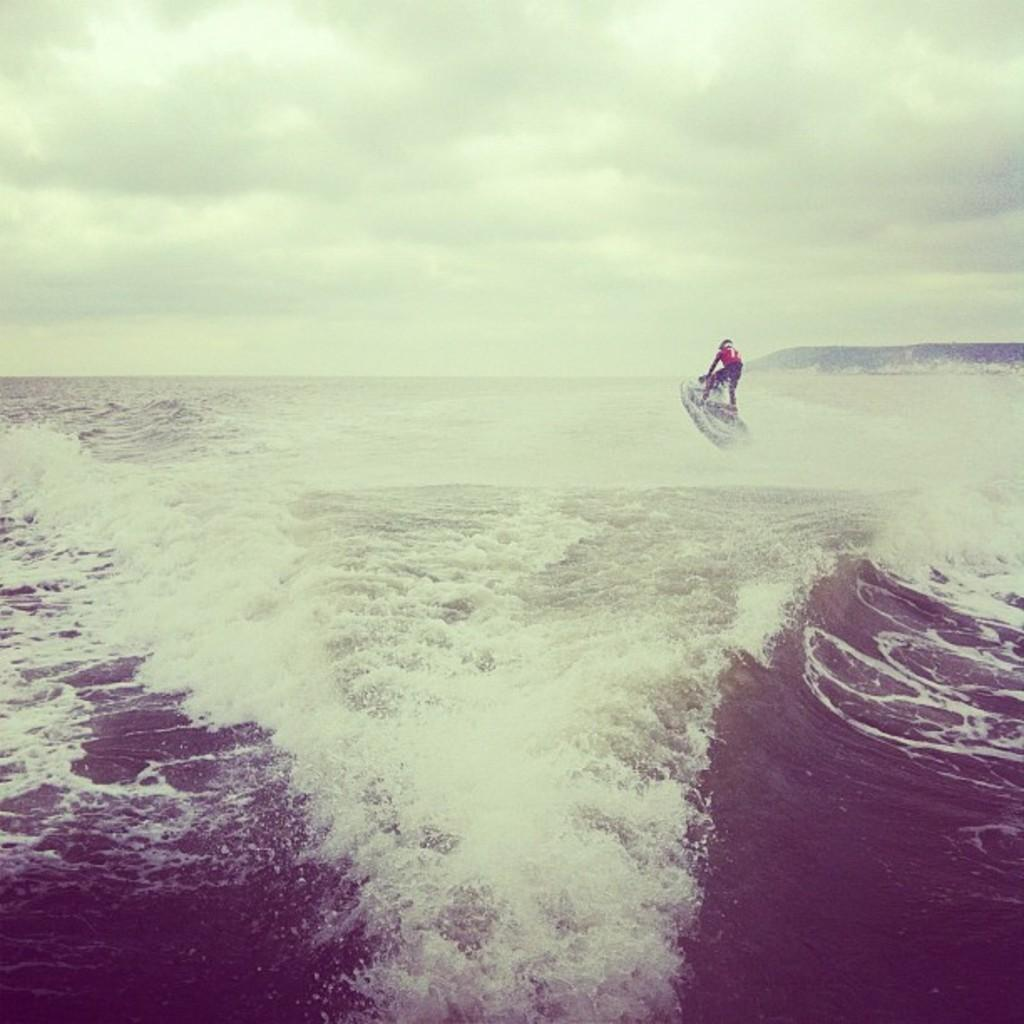What activity is the person in the image engaged in? There is a person boating in the water. What can be seen in the right corner of the image? There is a mountain in the right corner of the image. How would you describe the sky in the image? The sky is cloudy. How does the person in the image feel about the houses in the area? There are no houses mentioned or visible in the image, so it is impossible to determine how the person feels about them. 